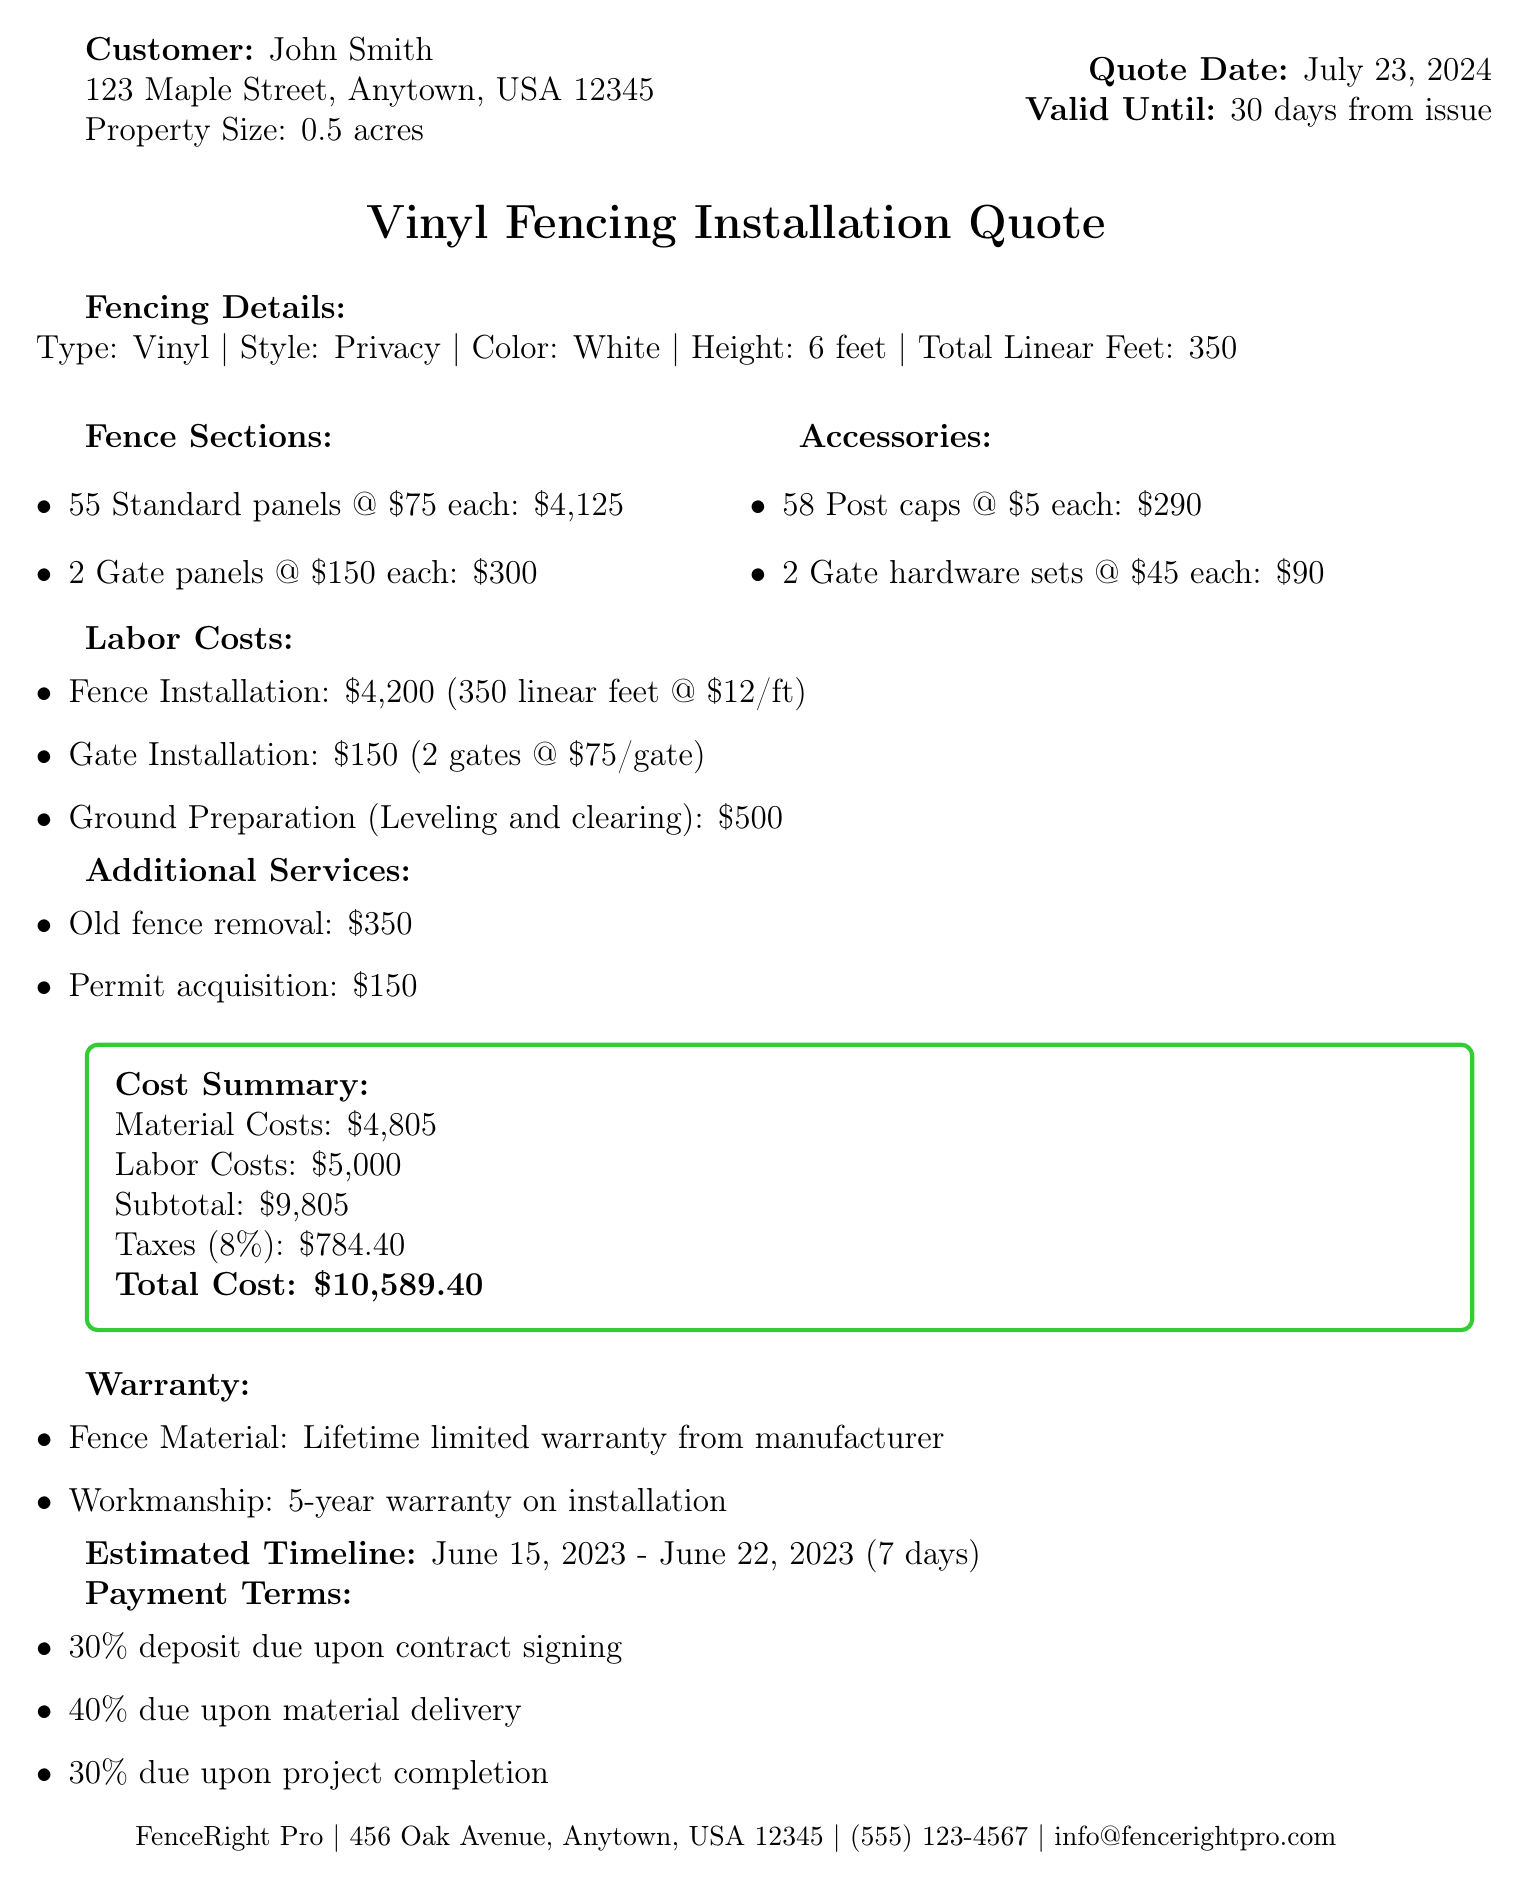What is the name of the customer? The document contains customer information, where the name listed is John Smith.
Answer: John Smith What is the total linear feet of fencing? The document states that the total linear feet of fencing is given as 350 feet.
Answer: 350 feet What is the total cost of the vinyl fencing installation? The document shows a breakdown, and the total cost is explicitly mentioned at the end.
Answer: $10,589.40 How many standard panels are included in the quote? The breakdown in the document specifies the quantity of standard panels included as 55.
Answer: 55 What is the warranty period for the workmanship? The document indicates a 5-year warranty on installation for workmanship.
Answer: 5 years What is the tax rate applied to the total cost? The tax rate is explicitly stated in the document, as a percentage.
Answer: 8% What is the total price for post caps? The document provides a calculation for accessories, specifically for post caps, totaling to a specific amount.
Answer: $290 What is the scheduled start date for the installation? The estimated timeline in the document details the start date for the project as June 15, 2023.
Answer: June 15, 2023 What percentage is due as a deposit upon contract signing? The payment terms section of the document specifies the deposit percentage due at contract signing.
Answer: 30% 